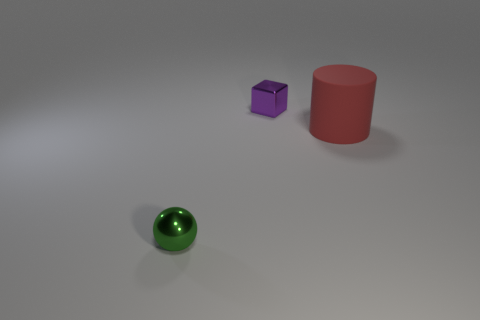Is the number of red matte objects that are to the left of the big matte object less than the number of small yellow cylinders?
Give a very brief answer. No. Are any big red objects visible?
Offer a terse response. Yes. What is the material of the tiny thing left of the tiny purple metallic object that is behind the metal sphere?
Provide a short and direct response. Metal. What is the color of the big cylinder?
Provide a succinct answer. Red. Is there a large rubber cylinder of the same color as the big object?
Keep it short and to the point. No. How many small objects are the same color as the tiny block?
Give a very brief answer. 0. What number of things are either objects left of the small metallic block or matte cylinders?
Provide a short and direct response. 2. What color is the small object that is the same material as the cube?
Your answer should be very brief. Green. Is there a metal sphere that has the same size as the purple metallic object?
Provide a succinct answer. Yes. How many objects are either things to the right of the ball or tiny metallic objects that are behind the small green shiny object?
Provide a short and direct response. 2. 